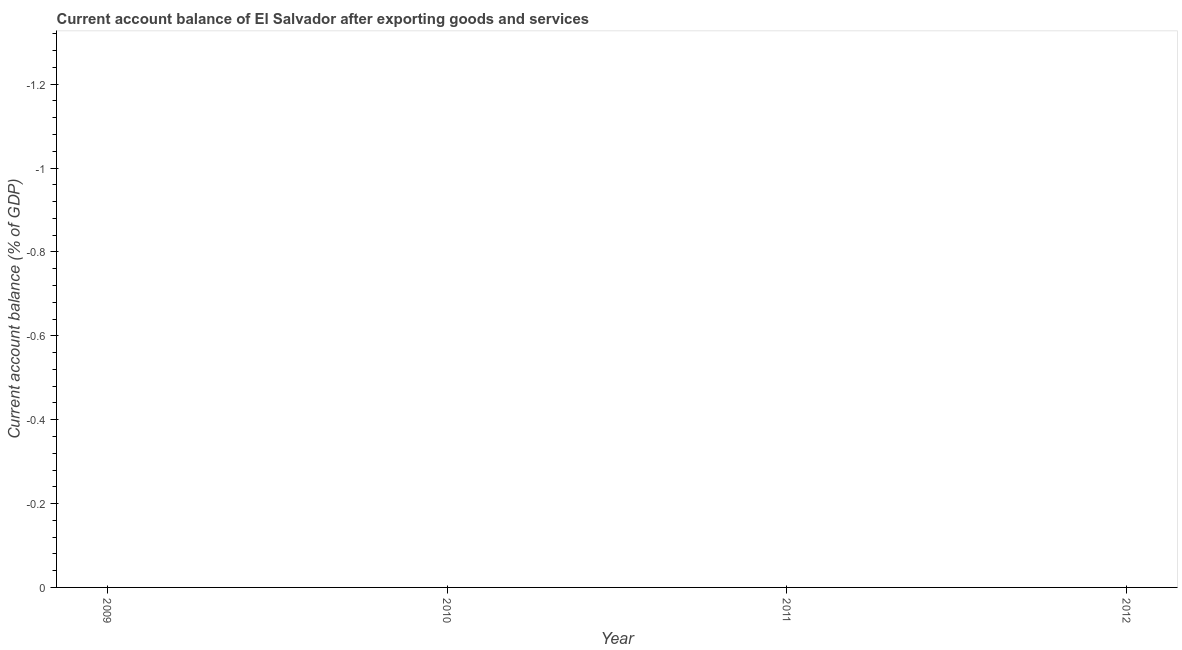Across all years, what is the minimum current account balance?
Provide a short and direct response. 0. What is the median current account balance?
Your answer should be very brief. 0. In how many years, is the current account balance greater than the average current account balance taken over all years?
Offer a very short reply. 0. How many dotlines are there?
Keep it short and to the point. 0. How many years are there in the graph?
Keep it short and to the point. 4. What is the difference between two consecutive major ticks on the Y-axis?
Make the answer very short. 0.2. Are the values on the major ticks of Y-axis written in scientific E-notation?
Give a very brief answer. No. Does the graph contain any zero values?
Provide a short and direct response. Yes. Does the graph contain grids?
Offer a terse response. No. What is the title of the graph?
Ensure brevity in your answer.  Current account balance of El Salvador after exporting goods and services. What is the label or title of the Y-axis?
Your response must be concise. Current account balance (% of GDP). What is the Current account balance (% of GDP) in 2009?
Offer a very short reply. 0. What is the Current account balance (% of GDP) in 2010?
Your answer should be very brief. 0. What is the Current account balance (% of GDP) in 2012?
Make the answer very short. 0. 